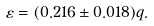Convert formula to latex. <formula><loc_0><loc_0><loc_500><loc_500>\varepsilon = ( 0 . 2 1 6 \pm 0 . 0 1 8 ) q .</formula> 